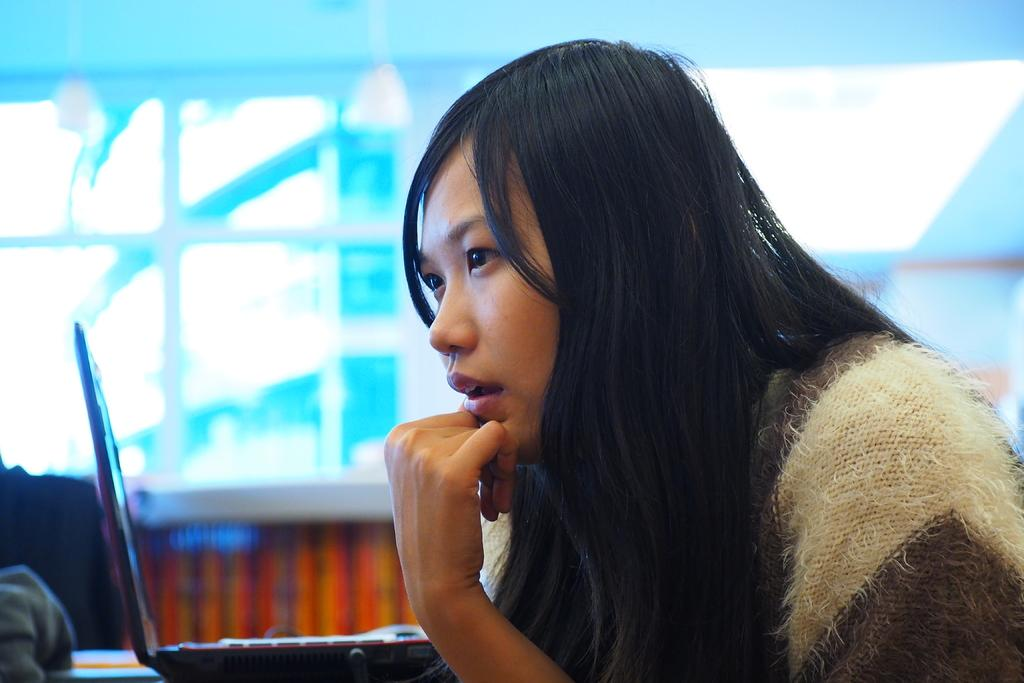What is located on the left side of the image? There is a table on the left side of the image. What is placed on the table? A laptop is placed on the table. What can be seen in the center of the image? There is a lady sitting in the center of the image. What is visible in the background of the image? There is a wall in the background of the image. Can you see any pens bursting into mist in the image? No, there are no pens, bursting, or mist present in the image. 